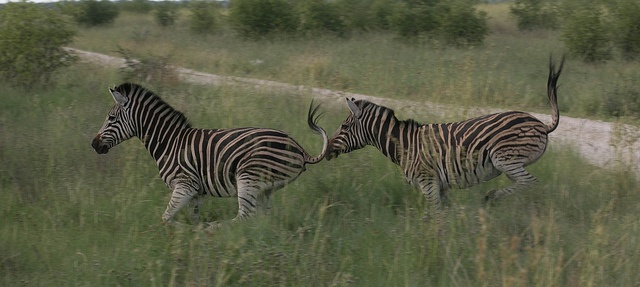Describe the objects in this image and their specific colors. I can see zebra in white, black, gray, and darkgray tones and zebra in white, gray, and black tones in this image. 